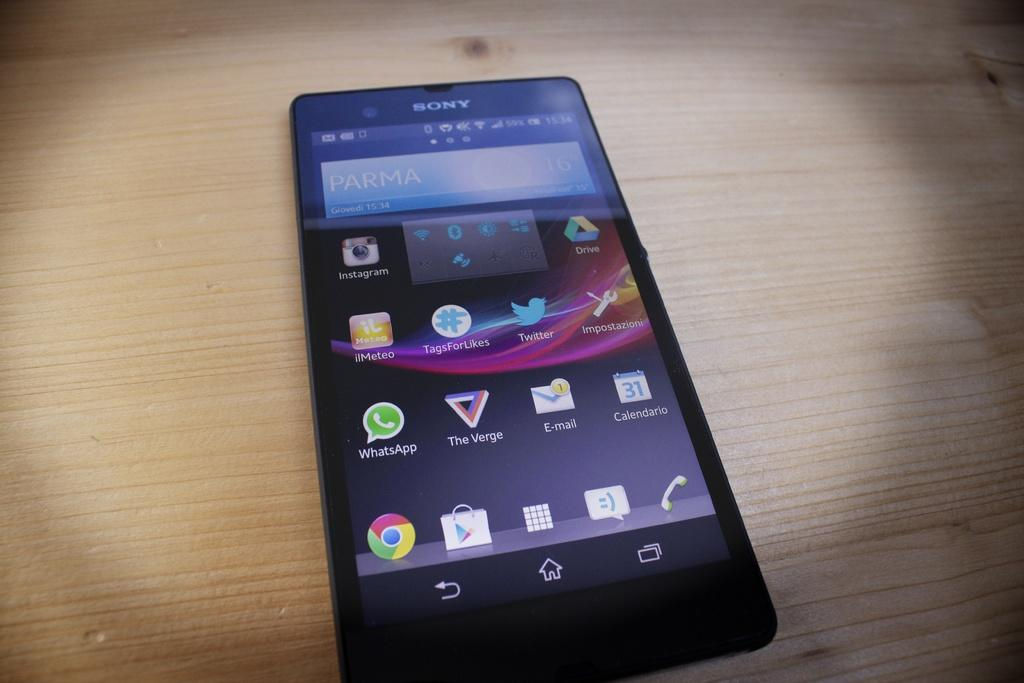<image>
Summarize the visual content of the image. Four rows of icons are visible on a Sony phone. 